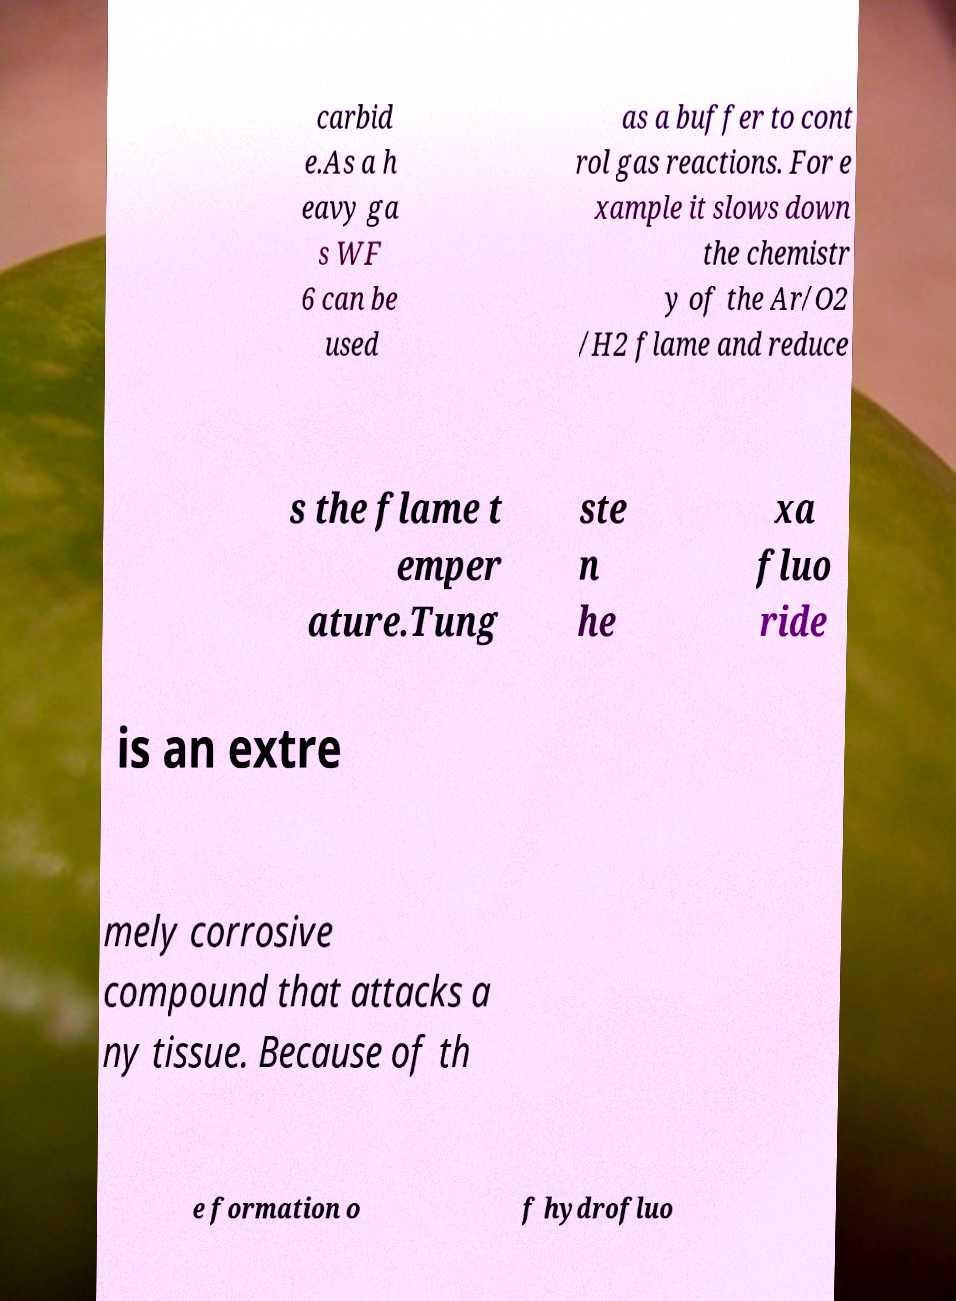I need the written content from this picture converted into text. Can you do that? carbid e.As a h eavy ga s WF 6 can be used as a buffer to cont rol gas reactions. For e xample it slows down the chemistr y of the Ar/O2 /H2 flame and reduce s the flame t emper ature.Tung ste n he xa fluo ride is an extre mely corrosive compound that attacks a ny tissue. Because of th e formation o f hydrofluo 